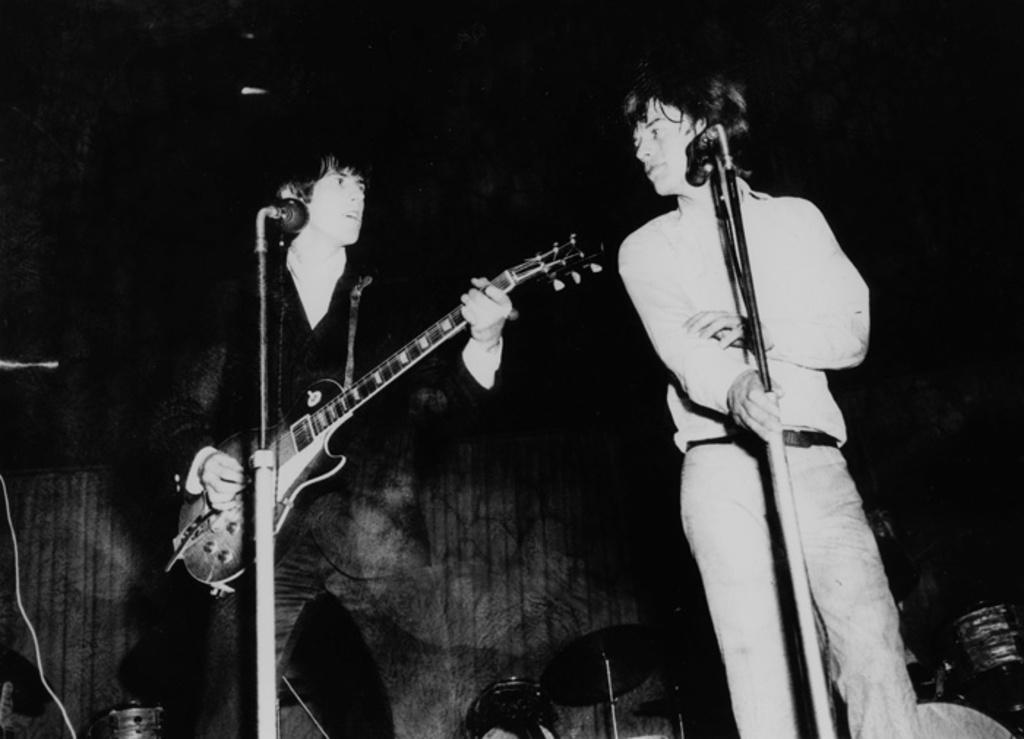How many people are in the image? There are two men standing in the image. What is one of the men holding? One man is holding a guitar in his hand. What objects are in front of the men? There are two microphones in front of the men. What type of sheet is draped over the guitar in the image? There is no sheet draped over the guitar in the image; the guitar is being held by one of the men. 